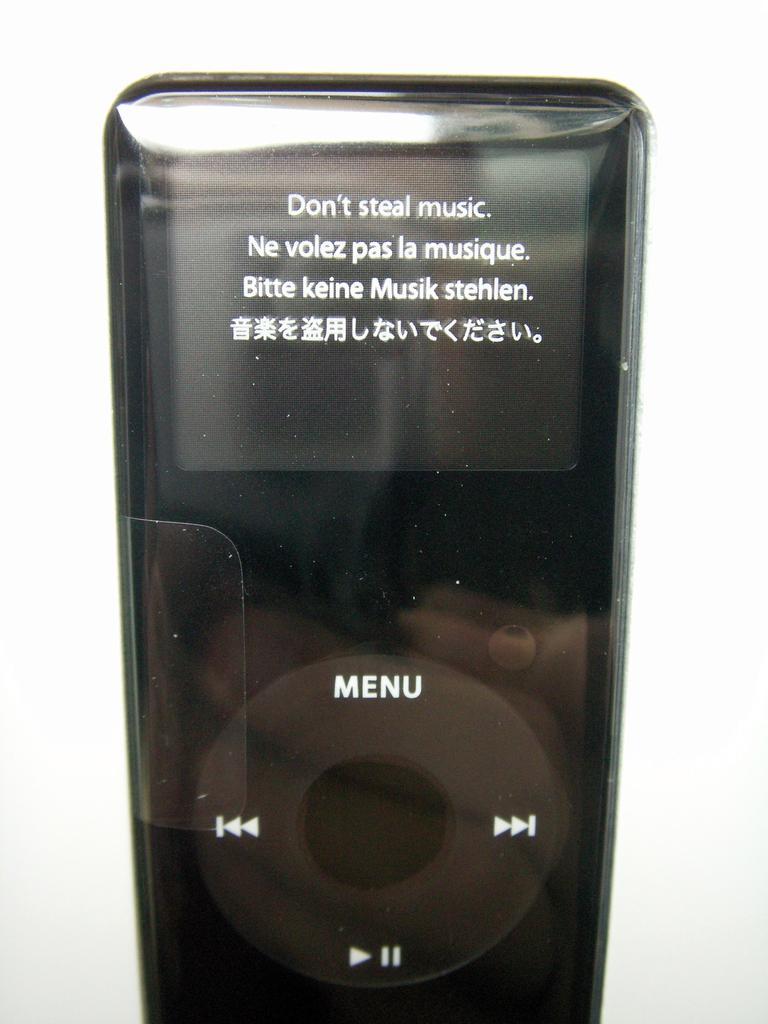Provide a one-sentence caption for the provided image. A black Apple iPod says Don't Steal Music. 